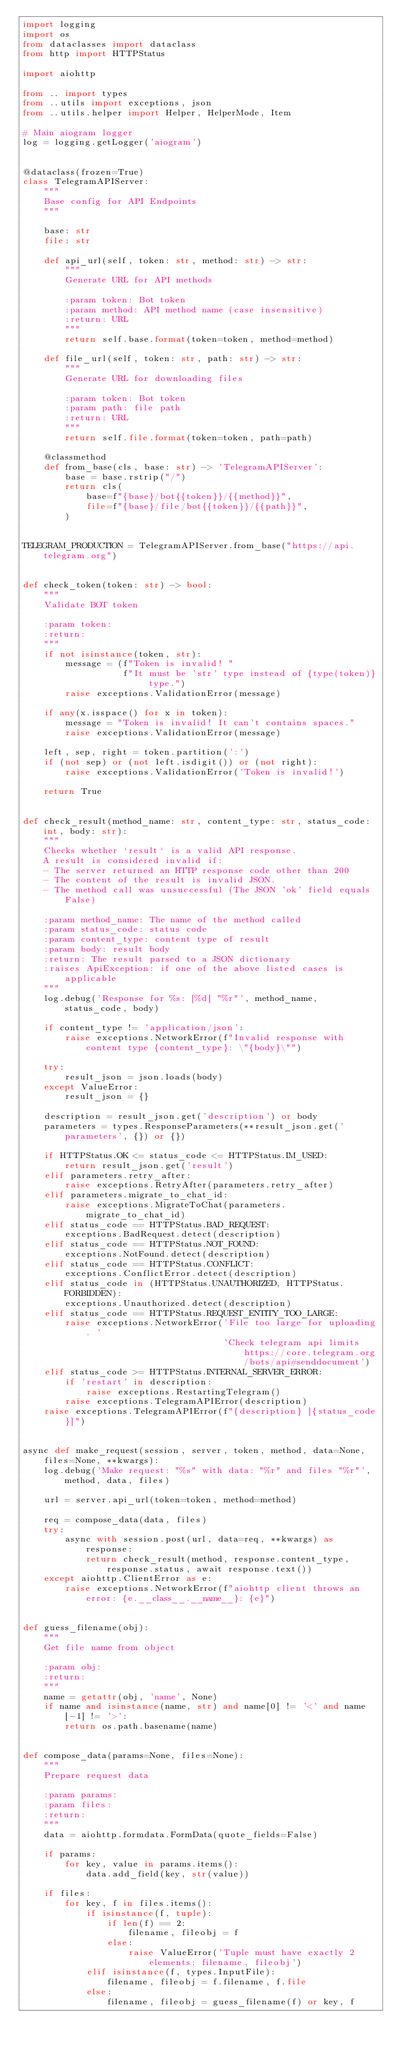Convert code to text. <code><loc_0><loc_0><loc_500><loc_500><_Python_>import logging
import os
from dataclasses import dataclass
from http import HTTPStatus

import aiohttp

from .. import types
from ..utils import exceptions, json
from ..utils.helper import Helper, HelperMode, Item

# Main aiogram logger
log = logging.getLogger('aiogram')


@dataclass(frozen=True)
class TelegramAPIServer:
    """
    Base config for API Endpoints
    """

    base: str
    file: str

    def api_url(self, token: str, method: str) -> str:
        """
        Generate URL for API methods

        :param token: Bot token
        :param method: API method name (case insensitive)
        :return: URL
        """
        return self.base.format(token=token, method=method)

    def file_url(self, token: str, path: str) -> str:
        """
        Generate URL for downloading files

        :param token: Bot token
        :param path: file path
        :return: URL
        """
        return self.file.format(token=token, path=path)

    @classmethod
    def from_base(cls, base: str) -> 'TelegramAPIServer':
        base = base.rstrip("/")
        return cls(
            base=f"{base}/bot{{token}}/{{method}}",
            file=f"{base}/file/bot{{token}}/{{path}}",
        )


TELEGRAM_PRODUCTION = TelegramAPIServer.from_base("https://api.telegram.org")


def check_token(token: str) -> bool:
    """
    Validate BOT token

    :param token:
    :return:
    """
    if not isinstance(token, str):
        message = (f"Token is invalid! "
                   f"It must be 'str' type instead of {type(token)} type.")
        raise exceptions.ValidationError(message)

    if any(x.isspace() for x in token):
        message = "Token is invalid! It can't contains spaces."
        raise exceptions.ValidationError(message)

    left, sep, right = token.partition(':')
    if (not sep) or (not left.isdigit()) or (not right):
        raise exceptions.ValidationError('Token is invalid!')

    return True


def check_result(method_name: str, content_type: str, status_code: int, body: str):
    """
    Checks whether `result` is a valid API response.
    A result is considered invalid if:
    - The server returned an HTTP response code other than 200
    - The content of the result is invalid JSON.
    - The method call was unsuccessful (The JSON 'ok' field equals False)

    :param method_name: The name of the method called
    :param status_code: status code
    :param content_type: content type of result
    :param body: result body
    :return: The result parsed to a JSON dictionary
    :raises ApiException: if one of the above listed cases is applicable
    """
    log.debug('Response for %s: [%d] "%r"', method_name, status_code, body)

    if content_type != 'application/json':
        raise exceptions.NetworkError(f"Invalid response with content type {content_type}: \"{body}\"")

    try:
        result_json = json.loads(body)
    except ValueError:
        result_json = {}

    description = result_json.get('description') or body
    parameters = types.ResponseParameters(**result_json.get('parameters', {}) or {})

    if HTTPStatus.OK <= status_code <= HTTPStatus.IM_USED:
        return result_json.get('result')
    elif parameters.retry_after:
        raise exceptions.RetryAfter(parameters.retry_after)
    elif parameters.migrate_to_chat_id:
        raise exceptions.MigrateToChat(parameters.migrate_to_chat_id)
    elif status_code == HTTPStatus.BAD_REQUEST:
        exceptions.BadRequest.detect(description)
    elif status_code == HTTPStatus.NOT_FOUND:
        exceptions.NotFound.detect(description)
    elif status_code == HTTPStatus.CONFLICT:
        exceptions.ConflictError.detect(description)
    elif status_code in (HTTPStatus.UNAUTHORIZED, HTTPStatus.FORBIDDEN):
        exceptions.Unauthorized.detect(description)
    elif status_code == HTTPStatus.REQUEST_ENTITY_TOO_LARGE:
        raise exceptions.NetworkError('File too large for uploading. '
                                      'Check telegram api limits https://core.telegram.org/bots/api#senddocument')
    elif status_code >= HTTPStatus.INTERNAL_SERVER_ERROR:
        if 'restart' in description:
            raise exceptions.RestartingTelegram()
        raise exceptions.TelegramAPIError(description)
    raise exceptions.TelegramAPIError(f"{description} [{status_code}]")


async def make_request(session, server, token, method, data=None, files=None, **kwargs):
    log.debug('Make request: "%s" with data: "%r" and files "%r"', method, data, files)

    url = server.api_url(token=token, method=method)

    req = compose_data(data, files)
    try:
        async with session.post(url, data=req, **kwargs) as response:
            return check_result(method, response.content_type, response.status, await response.text())
    except aiohttp.ClientError as e:
        raise exceptions.NetworkError(f"aiohttp client throws an error: {e.__class__.__name__}: {e}")


def guess_filename(obj):
    """
    Get file name from object

    :param obj:
    :return:
    """
    name = getattr(obj, 'name', None)
    if name and isinstance(name, str) and name[0] != '<' and name[-1] != '>':
        return os.path.basename(name)


def compose_data(params=None, files=None):
    """
    Prepare request data

    :param params:
    :param files:
    :return:
    """
    data = aiohttp.formdata.FormData(quote_fields=False)

    if params:
        for key, value in params.items():
            data.add_field(key, str(value))

    if files:
        for key, f in files.items():
            if isinstance(f, tuple):
                if len(f) == 2:
                    filename, fileobj = f
                else:
                    raise ValueError('Tuple must have exactly 2 elements: filename, fileobj')
            elif isinstance(f, types.InputFile):
                filename, fileobj = f.filename, f.file
            else:
                filename, fileobj = guess_filename(f) or key, f
</code> 